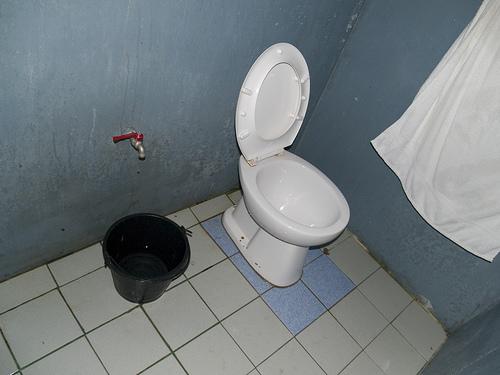Is this bathroom dirty?
Give a very brief answer. Yes. Is the seat up or down?
Keep it brief. Up. Is the sink missing in the photo?
Answer briefly. Yes. What is the black object?
Write a very short answer. Bucket. Is there a shoe in the image?
Be succinct. No. Is there any toilet paper?
Concise answer only. No. 